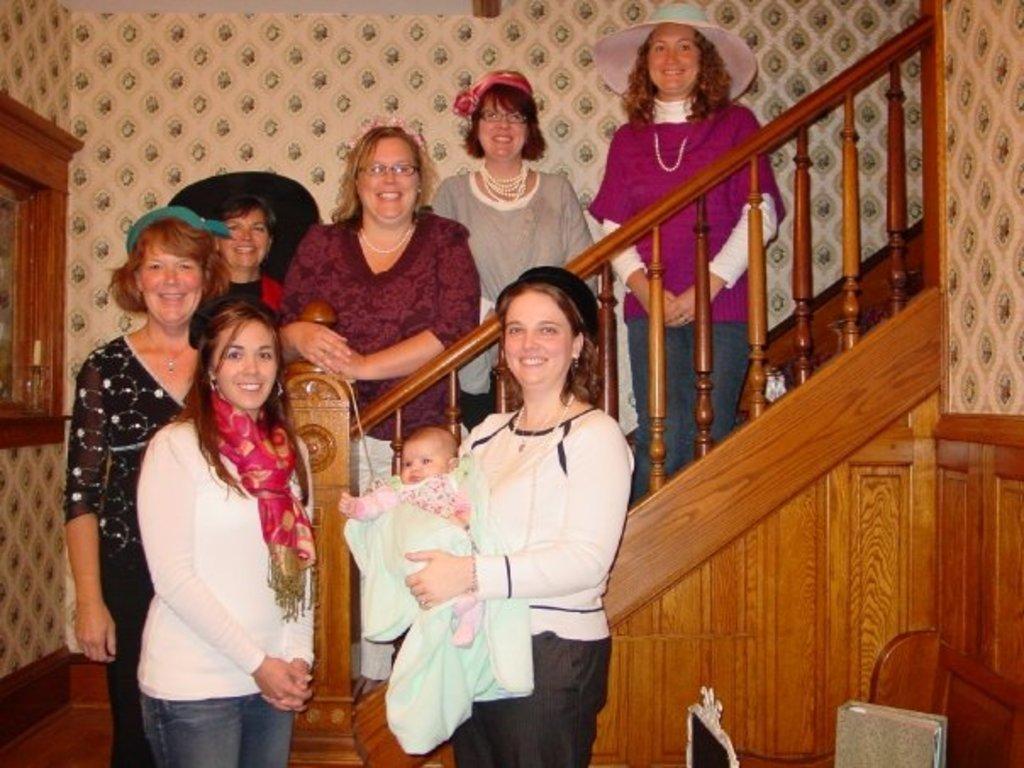How would you summarize this image in a sentence or two? In this picture we can see a group of people, they are smiling, one woman is carrying a baby and in the background we can see a staircase, wall and some objects. 